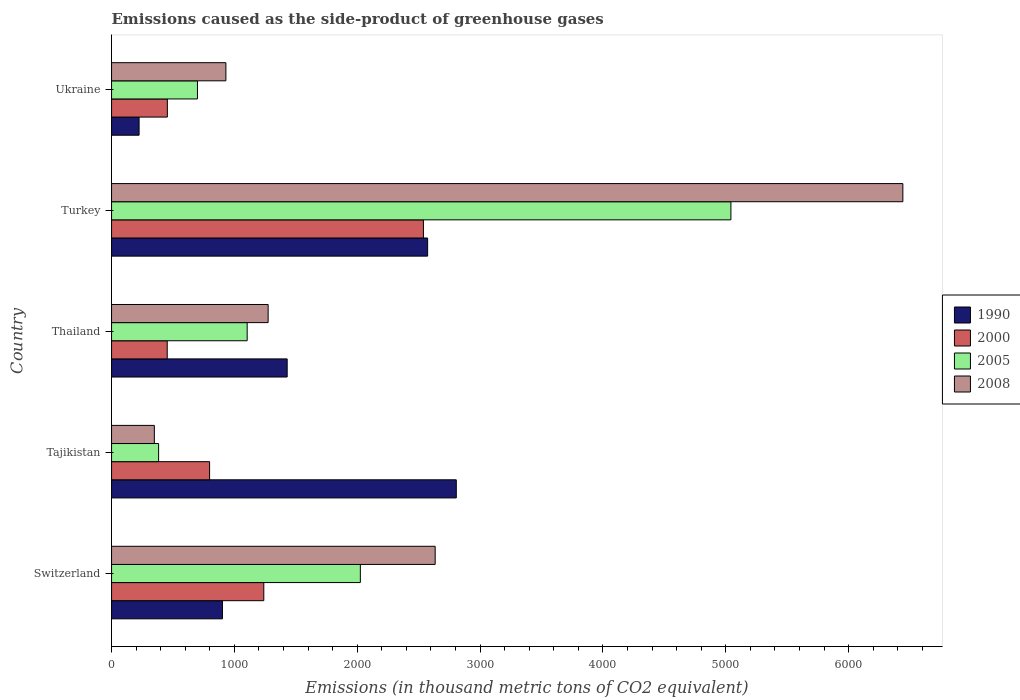How many different coloured bars are there?
Ensure brevity in your answer.  4. Are the number of bars per tick equal to the number of legend labels?
Provide a succinct answer. Yes. How many bars are there on the 4th tick from the bottom?
Make the answer very short. 4. What is the label of the 1st group of bars from the top?
Ensure brevity in your answer.  Ukraine. What is the emissions caused as the side-product of greenhouse gases in 2008 in Ukraine?
Make the answer very short. 930.6. Across all countries, what is the maximum emissions caused as the side-product of greenhouse gases in 1990?
Offer a terse response. 2806.1. Across all countries, what is the minimum emissions caused as the side-product of greenhouse gases in 2000?
Offer a very short reply. 453.1. In which country was the emissions caused as the side-product of greenhouse gases in 1990 maximum?
Your answer should be compact. Tajikistan. In which country was the emissions caused as the side-product of greenhouse gases in 1990 minimum?
Your answer should be very brief. Ukraine. What is the total emissions caused as the side-product of greenhouse gases in 2008 in the graph?
Offer a very short reply. 1.16e+04. What is the difference between the emissions caused as the side-product of greenhouse gases in 1990 in Thailand and that in Turkey?
Offer a terse response. -1143.2. What is the difference between the emissions caused as the side-product of greenhouse gases in 2000 in Tajikistan and the emissions caused as the side-product of greenhouse gases in 2008 in Thailand?
Provide a succinct answer. -476.5. What is the average emissions caused as the side-product of greenhouse gases in 2008 per country?
Give a very brief answer. 2325.7. What is the difference between the emissions caused as the side-product of greenhouse gases in 2005 and emissions caused as the side-product of greenhouse gases in 2008 in Switzerland?
Provide a short and direct response. -609.1. What is the ratio of the emissions caused as the side-product of greenhouse gases in 2000 in Switzerland to that in Turkey?
Your answer should be very brief. 0.49. Is the emissions caused as the side-product of greenhouse gases in 2005 in Thailand less than that in Ukraine?
Ensure brevity in your answer.  No. What is the difference between the highest and the second highest emissions caused as the side-product of greenhouse gases in 2000?
Give a very brief answer. 1299.3. What is the difference between the highest and the lowest emissions caused as the side-product of greenhouse gases in 1990?
Provide a succinct answer. 2582. Is the sum of the emissions caused as the side-product of greenhouse gases in 2000 in Tajikistan and Turkey greater than the maximum emissions caused as the side-product of greenhouse gases in 2008 across all countries?
Make the answer very short. No. Is it the case that in every country, the sum of the emissions caused as the side-product of greenhouse gases in 1990 and emissions caused as the side-product of greenhouse gases in 2005 is greater than the sum of emissions caused as the side-product of greenhouse gases in 2000 and emissions caused as the side-product of greenhouse gases in 2008?
Your response must be concise. No. What does the 4th bar from the top in Ukraine represents?
Ensure brevity in your answer.  1990. How many bars are there?
Your response must be concise. 20. What is the difference between two consecutive major ticks on the X-axis?
Your answer should be compact. 1000. Does the graph contain any zero values?
Provide a short and direct response. No. Does the graph contain grids?
Give a very brief answer. No. How many legend labels are there?
Offer a very short reply. 4. What is the title of the graph?
Offer a very short reply. Emissions caused as the side-product of greenhouse gases. What is the label or title of the X-axis?
Keep it short and to the point. Emissions (in thousand metric tons of CO2 equivalent). What is the Emissions (in thousand metric tons of CO2 equivalent) in 1990 in Switzerland?
Your answer should be compact. 902.6. What is the Emissions (in thousand metric tons of CO2 equivalent) in 2000 in Switzerland?
Give a very brief answer. 1239.2. What is the Emissions (in thousand metric tons of CO2 equivalent) of 2005 in Switzerland?
Your answer should be compact. 2025. What is the Emissions (in thousand metric tons of CO2 equivalent) of 2008 in Switzerland?
Make the answer very short. 2634.1. What is the Emissions (in thousand metric tons of CO2 equivalent) in 1990 in Tajikistan?
Provide a succinct answer. 2806.1. What is the Emissions (in thousand metric tons of CO2 equivalent) in 2000 in Tajikistan?
Provide a short and direct response. 798. What is the Emissions (in thousand metric tons of CO2 equivalent) in 2005 in Tajikistan?
Your answer should be very brief. 383. What is the Emissions (in thousand metric tons of CO2 equivalent) in 2008 in Tajikistan?
Keep it short and to the point. 348.3. What is the Emissions (in thousand metric tons of CO2 equivalent) in 1990 in Thailand?
Your answer should be very brief. 1429.5. What is the Emissions (in thousand metric tons of CO2 equivalent) in 2000 in Thailand?
Offer a very short reply. 453.1. What is the Emissions (in thousand metric tons of CO2 equivalent) of 2005 in Thailand?
Offer a very short reply. 1103.9. What is the Emissions (in thousand metric tons of CO2 equivalent) in 2008 in Thailand?
Your response must be concise. 1274.5. What is the Emissions (in thousand metric tons of CO2 equivalent) of 1990 in Turkey?
Offer a terse response. 2572.7. What is the Emissions (in thousand metric tons of CO2 equivalent) of 2000 in Turkey?
Provide a short and direct response. 2538.5. What is the Emissions (in thousand metric tons of CO2 equivalent) of 2005 in Turkey?
Ensure brevity in your answer.  5041.3. What is the Emissions (in thousand metric tons of CO2 equivalent) in 2008 in Turkey?
Your answer should be very brief. 6441. What is the Emissions (in thousand metric tons of CO2 equivalent) in 1990 in Ukraine?
Give a very brief answer. 224.1. What is the Emissions (in thousand metric tons of CO2 equivalent) of 2000 in Ukraine?
Ensure brevity in your answer.  454.2. What is the Emissions (in thousand metric tons of CO2 equivalent) of 2005 in Ukraine?
Give a very brief answer. 699.3. What is the Emissions (in thousand metric tons of CO2 equivalent) of 2008 in Ukraine?
Offer a very short reply. 930.6. Across all countries, what is the maximum Emissions (in thousand metric tons of CO2 equivalent) of 1990?
Your response must be concise. 2806.1. Across all countries, what is the maximum Emissions (in thousand metric tons of CO2 equivalent) of 2000?
Give a very brief answer. 2538.5. Across all countries, what is the maximum Emissions (in thousand metric tons of CO2 equivalent) in 2005?
Your response must be concise. 5041.3. Across all countries, what is the maximum Emissions (in thousand metric tons of CO2 equivalent) of 2008?
Your response must be concise. 6441. Across all countries, what is the minimum Emissions (in thousand metric tons of CO2 equivalent) in 1990?
Make the answer very short. 224.1. Across all countries, what is the minimum Emissions (in thousand metric tons of CO2 equivalent) of 2000?
Offer a terse response. 453.1. Across all countries, what is the minimum Emissions (in thousand metric tons of CO2 equivalent) in 2005?
Offer a terse response. 383. Across all countries, what is the minimum Emissions (in thousand metric tons of CO2 equivalent) of 2008?
Your answer should be compact. 348.3. What is the total Emissions (in thousand metric tons of CO2 equivalent) in 1990 in the graph?
Provide a short and direct response. 7935. What is the total Emissions (in thousand metric tons of CO2 equivalent) in 2000 in the graph?
Make the answer very short. 5483. What is the total Emissions (in thousand metric tons of CO2 equivalent) of 2005 in the graph?
Offer a very short reply. 9252.5. What is the total Emissions (in thousand metric tons of CO2 equivalent) in 2008 in the graph?
Offer a very short reply. 1.16e+04. What is the difference between the Emissions (in thousand metric tons of CO2 equivalent) in 1990 in Switzerland and that in Tajikistan?
Provide a short and direct response. -1903.5. What is the difference between the Emissions (in thousand metric tons of CO2 equivalent) in 2000 in Switzerland and that in Tajikistan?
Ensure brevity in your answer.  441.2. What is the difference between the Emissions (in thousand metric tons of CO2 equivalent) of 2005 in Switzerland and that in Tajikistan?
Provide a succinct answer. 1642. What is the difference between the Emissions (in thousand metric tons of CO2 equivalent) of 2008 in Switzerland and that in Tajikistan?
Keep it short and to the point. 2285.8. What is the difference between the Emissions (in thousand metric tons of CO2 equivalent) in 1990 in Switzerland and that in Thailand?
Provide a succinct answer. -526.9. What is the difference between the Emissions (in thousand metric tons of CO2 equivalent) in 2000 in Switzerland and that in Thailand?
Provide a short and direct response. 786.1. What is the difference between the Emissions (in thousand metric tons of CO2 equivalent) in 2005 in Switzerland and that in Thailand?
Your response must be concise. 921.1. What is the difference between the Emissions (in thousand metric tons of CO2 equivalent) of 2008 in Switzerland and that in Thailand?
Offer a terse response. 1359.6. What is the difference between the Emissions (in thousand metric tons of CO2 equivalent) of 1990 in Switzerland and that in Turkey?
Make the answer very short. -1670.1. What is the difference between the Emissions (in thousand metric tons of CO2 equivalent) of 2000 in Switzerland and that in Turkey?
Give a very brief answer. -1299.3. What is the difference between the Emissions (in thousand metric tons of CO2 equivalent) of 2005 in Switzerland and that in Turkey?
Provide a short and direct response. -3016.3. What is the difference between the Emissions (in thousand metric tons of CO2 equivalent) of 2008 in Switzerland and that in Turkey?
Make the answer very short. -3806.9. What is the difference between the Emissions (in thousand metric tons of CO2 equivalent) of 1990 in Switzerland and that in Ukraine?
Offer a terse response. 678.5. What is the difference between the Emissions (in thousand metric tons of CO2 equivalent) of 2000 in Switzerland and that in Ukraine?
Your response must be concise. 785. What is the difference between the Emissions (in thousand metric tons of CO2 equivalent) in 2005 in Switzerland and that in Ukraine?
Your answer should be compact. 1325.7. What is the difference between the Emissions (in thousand metric tons of CO2 equivalent) in 2008 in Switzerland and that in Ukraine?
Your response must be concise. 1703.5. What is the difference between the Emissions (in thousand metric tons of CO2 equivalent) of 1990 in Tajikistan and that in Thailand?
Ensure brevity in your answer.  1376.6. What is the difference between the Emissions (in thousand metric tons of CO2 equivalent) of 2000 in Tajikistan and that in Thailand?
Offer a terse response. 344.9. What is the difference between the Emissions (in thousand metric tons of CO2 equivalent) in 2005 in Tajikistan and that in Thailand?
Your answer should be compact. -720.9. What is the difference between the Emissions (in thousand metric tons of CO2 equivalent) of 2008 in Tajikistan and that in Thailand?
Ensure brevity in your answer.  -926.2. What is the difference between the Emissions (in thousand metric tons of CO2 equivalent) in 1990 in Tajikistan and that in Turkey?
Your response must be concise. 233.4. What is the difference between the Emissions (in thousand metric tons of CO2 equivalent) of 2000 in Tajikistan and that in Turkey?
Offer a terse response. -1740.5. What is the difference between the Emissions (in thousand metric tons of CO2 equivalent) of 2005 in Tajikistan and that in Turkey?
Offer a terse response. -4658.3. What is the difference between the Emissions (in thousand metric tons of CO2 equivalent) of 2008 in Tajikistan and that in Turkey?
Keep it short and to the point. -6092.7. What is the difference between the Emissions (in thousand metric tons of CO2 equivalent) of 1990 in Tajikistan and that in Ukraine?
Provide a succinct answer. 2582. What is the difference between the Emissions (in thousand metric tons of CO2 equivalent) of 2000 in Tajikistan and that in Ukraine?
Your answer should be very brief. 343.8. What is the difference between the Emissions (in thousand metric tons of CO2 equivalent) in 2005 in Tajikistan and that in Ukraine?
Your response must be concise. -316.3. What is the difference between the Emissions (in thousand metric tons of CO2 equivalent) in 2008 in Tajikistan and that in Ukraine?
Your response must be concise. -582.3. What is the difference between the Emissions (in thousand metric tons of CO2 equivalent) in 1990 in Thailand and that in Turkey?
Your response must be concise. -1143.2. What is the difference between the Emissions (in thousand metric tons of CO2 equivalent) of 2000 in Thailand and that in Turkey?
Provide a short and direct response. -2085.4. What is the difference between the Emissions (in thousand metric tons of CO2 equivalent) in 2005 in Thailand and that in Turkey?
Make the answer very short. -3937.4. What is the difference between the Emissions (in thousand metric tons of CO2 equivalent) in 2008 in Thailand and that in Turkey?
Give a very brief answer. -5166.5. What is the difference between the Emissions (in thousand metric tons of CO2 equivalent) in 1990 in Thailand and that in Ukraine?
Your answer should be very brief. 1205.4. What is the difference between the Emissions (in thousand metric tons of CO2 equivalent) of 2005 in Thailand and that in Ukraine?
Offer a very short reply. 404.6. What is the difference between the Emissions (in thousand metric tons of CO2 equivalent) of 2008 in Thailand and that in Ukraine?
Offer a very short reply. 343.9. What is the difference between the Emissions (in thousand metric tons of CO2 equivalent) of 1990 in Turkey and that in Ukraine?
Provide a succinct answer. 2348.6. What is the difference between the Emissions (in thousand metric tons of CO2 equivalent) of 2000 in Turkey and that in Ukraine?
Ensure brevity in your answer.  2084.3. What is the difference between the Emissions (in thousand metric tons of CO2 equivalent) of 2005 in Turkey and that in Ukraine?
Give a very brief answer. 4342. What is the difference between the Emissions (in thousand metric tons of CO2 equivalent) of 2008 in Turkey and that in Ukraine?
Your answer should be compact. 5510.4. What is the difference between the Emissions (in thousand metric tons of CO2 equivalent) of 1990 in Switzerland and the Emissions (in thousand metric tons of CO2 equivalent) of 2000 in Tajikistan?
Your answer should be compact. 104.6. What is the difference between the Emissions (in thousand metric tons of CO2 equivalent) of 1990 in Switzerland and the Emissions (in thousand metric tons of CO2 equivalent) of 2005 in Tajikistan?
Make the answer very short. 519.6. What is the difference between the Emissions (in thousand metric tons of CO2 equivalent) in 1990 in Switzerland and the Emissions (in thousand metric tons of CO2 equivalent) in 2008 in Tajikistan?
Your answer should be very brief. 554.3. What is the difference between the Emissions (in thousand metric tons of CO2 equivalent) in 2000 in Switzerland and the Emissions (in thousand metric tons of CO2 equivalent) in 2005 in Tajikistan?
Provide a succinct answer. 856.2. What is the difference between the Emissions (in thousand metric tons of CO2 equivalent) of 2000 in Switzerland and the Emissions (in thousand metric tons of CO2 equivalent) of 2008 in Tajikistan?
Ensure brevity in your answer.  890.9. What is the difference between the Emissions (in thousand metric tons of CO2 equivalent) of 2005 in Switzerland and the Emissions (in thousand metric tons of CO2 equivalent) of 2008 in Tajikistan?
Your answer should be compact. 1676.7. What is the difference between the Emissions (in thousand metric tons of CO2 equivalent) in 1990 in Switzerland and the Emissions (in thousand metric tons of CO2 equivalent) in 2000 in Thailand?
Make the answer very short. 449.5. What is the difference between the Emissions (in thousand metric tons of CO2 equivalent) in 1990 in Switzerland and the Emissions (in thousand metric tons of CO2 equivalent) in 2005 in Thailand?
Offer a very short reply. -201.3. What is the difference between the Emissions (in thousand metric tons of CO2 equivalent) in 1990 in Switzerland and the Emissions (in thousand metric tons of CO2 equivalent) in 2008 in Thailand?
Make the answer very short. -371.9. What is the difference between the Emissions (in thousand metric tons of CO2 equivalent) in 2000 in Switzerland and the Emissions (in thousand metric tons of CO2 equivalent) in 2005 in Thailand?
Offer a very short reply. 135.3. What is the difference between the Emissions (in thousand metric tons of CO2 equivalent) of 2000 in Switzerland and the Emissions (in thousand metric tons of CO2 equivalent) of 2008 in Thailand?
Provide a succinct answer. -35.3. What is the difference between the Emissions (in thousand metric tons of CO2 equivalent) in 2005 in Switzerland and the Emissions (in thousand metric tons of CO2 equivalent) in 2008 in Thailand?
Offer a terse response. 750.5. What is the difference between the Emissions (in thousand metric tons of CO2 equivalent) in 1990 in Switzerland and the Emissions (in thousand metric tons of CO2 equivalent) in 2000 in Turkey?
Provide a succinct answer. -1635.9. What is the difference between the Emissions (in thousand metric tons of CO2 equivalent) in 1990 in Switzerland and the Emissions (in thousand metric tons of CO2 equivalent) in 2005 in Turkey?
Your answer should be very brief. -4138.7. What is the difference between the Emissions (in thousand metric tons of CO2 equivalent) in 1990 in Switzerland and the Emissions (in thousand metric tons of CO2 equivalent) in 2008 in Turkey?
Your response must be concise. -5538.4. What is the difference between the Emissions (in thousand metric tons of CO2 equivalent) of 2000 in Switzerland and the Emissions (in thousand metric tons of CO2 equivalent) of 2005 in Turkey?
Keep it short and to the point. -3802.1. What is the difference between the Emissions (in thousand metric tons of CO2 equivalent) of 2000 in Switzerland and the Emissions (in thousand metric tons of CO2 equivalent) of 2008 in Turkey?
Ensure brevity in your answer.  -5201.8. What is the difference between the Emissions (in thousand metric tons of CO2 equivalent) of 2005 in Switzerland and the Emissions (in thousand metric tons of CO2 equivalent) of 2008 in Turkey?
Give a very brief answer. -4416. What is the difference between the Emissions (in thousand metric tons of CO2 equivalent) of 1990 in Switzerland and the Emissions (in thousand metric tons of CO2 equivalent) of 2000 in Ukraine?
Your response must be concise. 448.4. What is the difference between the Emissions (in thousand metric tons of CO2 equivalent) in 1990 in Switzerland and the Emissions (in thousand metric tons of CO2 equivalent) in 2005 in Ukraine?
Offer a very short reply. 203.3. What is the difference between the Emissions (in thousand metric tons of CO2 equivalent) in 1990 in Switzerland and the Emissions (in thousand metric tons of CO2 equivalent) in 2008 in Ukraine?
Your response must be concise. -28. What is the difference between the Emissions (in thousand metric tons of CO2 equivalent) of 2000 in Switzerland and the Emissions (in thousand metric tons of CO2 equivalent) of 2005 in Ukraine?
Offer a very short reply. 539.9. What is the difference between the Emissions (in thousand metric tons of CO2 equivalent) of 2000 in Switzerland and the Emissions (in thousand metric tons of CO2 equivalent) of 2008 in Ukraine?
Provide a succinct answer. 308.6. What is the difference between the Emissions (in thousand metric tons of CO2 equivalent) of 2005 in Switzerland and the Emissions (in thousand metric tons of CO2 equivalent) of 2008 in Ukraine?
Ensure brevity in your answer.  1094.4. What is the difference between the Emissions (in thousand metric tons of CO2 equivalent) in 1990 in Tajikistan and the Emissions (in thousand metric tons of CO2 equivalent) in 2000 in Thailand?
Offer a very short reply. 2353. What is the difference between the Emissions (in thousand metric tons of CO2 equivalent) of 1990 in Tajikistan and the Emissions (in thousand metric tons of CO2 equivalent) of 2005 in Thailand?
Make the answer very short. 1702.2. What is the difference between the Emissions (in thousand metric tons of CO2 equivalent) in 1990 in Tajikistan and the Emissions (in thousand metric tons of CO2 equivalent) in 2008 in Thailand?
Your response must be concise. 1531.6. What is the difference between the Emissions (in thousand metric tons of CO2 equivalent) in 2000 in Tajikistan and the Emissions (in thousand metric tons of CO2 equivalent) in 2005 in Thailand?
Give a very brief answer. -305.9. What is the difference between the Emissions (in thousand metric tons of CO2 equivalent) of 2000 in Tajikistan and the Emissions (in thousand metric tons of CO2 equivalent) of 2008 in Thailand?
Your response must be concise. -476.5. What is the difference between the Emissions (in thousand metric tons of CO2 equivalent) of 2005 in Tajikistan and the Emissions (in thousand metric tons of CO2 equivalent) of 2008 in Thailand?
Your answer should be compact. -891.5. What is the difference between the Emissions (in thousand metric tons of CO2 equivalent) of 1990 in Tajikistan and the Emissions (in thousand metric tons of CO2 equivalent) of 2000 in Turkey?
Ensure brevity in your answer.  267.6. What is the difference between the Emissions (in thousand metric tons of CO2 equivalent) of 1990 in Tajikistan and the Emissions (in thousand metric tons of CO2 equivalent) of 2005 in Turkey?
Your response must be concise. -2235.2. What is the difference between the Emissions (in thousand metric tons of CO2 equivalent) of 1990 in Tajikistan and the Emissions (in thousand metric tons of CO2 equivalent) of 2008 in Turkey?
Provide a succinct answer. -3634.9. What is the difference between the Emissions (in thousand metric tons of CO2 equivalent) in 2000 in Tajikistan and the Emissions (in thousand metric tons of CO2 equivalent) in 2005 in Turkey?
Make the answer very short. -4243.3. What is the difference between the Emissions (in thousand metric tons of CO2 equivalent) in 2000 in Tajikistan and the Emissions (in thousand metric tons of CO2 equivalent) in 2008 in Turkey?
Provide a short and direct response. -5643. What is the difference between the Emissions (in thousand metric tons of CO2 equivalent) of 2005 in Tajikistan and the Emissions (in thousand metric tons of CO2 equivalent) of 2008 in Turkey?
Your answer should be compact. -6058. What is the difference between the Emissions (in thousand metric tons of CO2 equivalent) in 1990 in Tajikistan and the Emissions (in thousand metric tons of CO2 equivalent) in 2000 in Ukraine?
Offer a terse response. 2351.9. What is the difference between the Emissions (in thousand metric tons of CO2 equivalent) in 1990 in Tajikistan and the Emissions (in thousand metric tons of CO2 equivalent) in 2005 in Ukraine?
Make the answer very short. 2106.8. What is the difference between the Emissions (in thousand metric tons of CO2 equivalent) in 1990 in Tajikistan and the Emissions (in thousand metric tons of CO2 equivalent) in 2008 in Ukraine?
Ensure brevity in your answer.  1875.5. What is the difference between the Emissions (in thousand metric tons of CO2 equivalent) in 2000 in Tajikistan and the Emissions (in thousand metric tons of CO2 equivalent) in 2005 in Ukraine?
Your answer should be compact. 98.7. What is the difference between the Emissions (in thousand metric tons of CO2 equivalent) in 2000 in Tajikistan and the Emissions (in thousand metric tons of CO2 equivalent) in 2008 in Ukraine?
Make the answer very short. -132.6. What is the difference between the Emissions (in thousand metric tons of CO2 equivalent) of 2005 in Tajikistan and the Emissions (in thousand metric tons of CO2 equivalent) of 2008 in Ukraine?
Offer a terse response. -547.6. What is the difference between the Emissions (in thousand metric tons of CO2 equivalent) of 1990 in Thailand and the Emissions (in thousand metric tons of CO2 equivalent) of 2000 in Turkey?
Your response must be concise. -1109. What is the difference between the Emissions (in thousand metric tons of CO2 equivalent) in 1990 in Thailand and the Emissions (in thousand metric tons of CO2 equivalent) in 2005 in Turkey?
Your answer should be very brief. -3611.8. What is the difference between the Emissions (in thousand metric tons of CO2 equivalent) of 1990 in Thailand and the Emissions (in thousand metric tons of CO2 equivalent) of 2008 in Turkey?
Ensure brevity in your answer.  -5011.5. What is the difference between the Emissions (in thousand metric tons of CO2 equivalent) in 2000 in Thailand and the Emissions (in thousand metric tons of CO2 equivalent) in 2005 in Turkey?
Offer a terse response. -4588.2. What is the difference between the Emissions (in thousand metric tons of CO2 equivalent) of 2000 in Thailand and the Emissions (in thousand metric tons of CO2 equivalent) of 2008 in Turkey?
Your answer should be compact. -5987.9. What is the difference between the Emissions (in thousand metric tons of CO2 equivalent) of 2005 in Thailand and the Emissions (in thousand metric tons of CO2 equivalent) of 2008 in Turkey?
Your answer should be very brief. -5337.1. What is the difference between the Emissions (in thousand metric tons of CO2 equivalent) of 1990 in Thailand and the Emissions (in thousand metric tons of CO2 equivalent) of 2000 in Ukraine?
Your answer should be compact. 975.3. What is the difference between the Emissions (in thousand metric tons of CO2 equivalent) in 1990 in Thailand and the Emissions (in thousand metric tons of CO2 equivalent) in 2005 in Ukraine?
Offer a terse response. 730.2. What is the difference between the Emissions (in thousand metric tons of CO2 equivalent) of 1990 in Thailand and the Emissions (in thousand metric tons of CO2 equivalent) of 2008 in Ukraine?
Ensure brevity in your answer.  498.9. What is the difference between the Emissions (in thousand metric tons of CO2 equivalent) in 2000 in Thailand and the Emissions (in thousand metric tons of CO2 equivalent) in 2005 in Ukraine?
Give a very brief answer. -246.2. What is the difference between the Emissions (in thousand metric tons of CO2 equivalent) in 2000 in Thailand and the Emissions (in thousand metric tons of CO2 equivalent) in 2008 in Ukraine?
Offer a very short reply. -477.5. What is the difference between the Emissions (in thousand metric tons of CO2 equivalent) in 2005 in Thailand and the Emissions (in thousand metric tons of CO2 equivalent) in 2008 in Ukraine?
Give a very brief answer. 173.3. What is the difference between the Emissions (in thousand metric tons of CO2 equivalent) in 1990 in Turkey and the Emissions (in thousand metric tons of CO2 equivalent) in 2000 in Ukraine?
Offer a very short reply. 2118.5. What is the difference between the Emissions (in thousand metric tons of CO2 equivalent) in 1990 in Turkey and the Emissions (in thousand metric tons of CO2 equivalent) in 2005 in Ukraine?
Make the answer very short. 1873.4. What is the difference between the Emissions (in thousand metric tons of CO2 equivalent) of 1990 in Turkey and the Emissions (in thousand metric tons of CO2 equivalent) of 2008 in Ukraine?
Offer a terse response. 1642.1. What is the difference between the Emissions (in thousand metric tons of CO2 equivalent) in 2000 in Turkey and the Emissions (in thousand metric tons of CO2 equivalent) in 2005 in Ukraine?
Ensure brevity in your answer.  1839.2. What is the difference between the Emissions (in thousand metric tons of CO2 equivalent) in 2000 in Turkey and the Emissions (in thousand metric tons of CO2 equivalent) in 2008 in Ukraine?
Provide a short and direct response. 1607.9. What is the difference between the Emissions (in thousand metric tons of CO2 equivalent) in 2005 in Turkey and the Emissions (in thousand metric tons of CO2 equivalent) in 2008 in Ukraine?
Your answer should be compact. 4110.7. What is the average Emissions (in thousand metric tons of CO2 equivalent) of 1990 per country?
Your answer should be very brief. 1587. What is the average Emissions (in thousand metric tons of CO2 equivalent) of 2000 per country?
Your response must be concise. 1096.6. What is the average Emissions (in thousand metric tons of CO2 equivalent) in 2005 per country?
Provide a short and direct response. 1850.5. What is the average Emissions (in thousand metric tons of CO2 equivalent) of 2008 per country?
Ensure brevity in your answer.  2325.7. What is the difference between the Emissions (in thousand metric tons of CO2 equivalent) of 1990 and Emissions (in thousand metric tons of CO2 equivalent) of 2000 in Switzerland?
Give a very brief answer. -336.6. What is the difference between the Emissions (in thousand metric tons of CO2 equivalent) in 1990 and Emissions (in thousand metric tons of CO2 equivalent) in 2005 in Switzerland?
Provide a succinct answer. -1122.4. What is the difference between the Emissions (in thousand metric tons of CO2 equivalent) in 1990 and Emissions (in thousand metric tons of CO2 equivalent) in 2008 in Switzerland?
Make the answer very short. -1731.5. What is the difference between the Emissions (in thousand metric tons of CO2 equivalent) of 2000 and Emissions (in thousand metric tons of CO2 equivalent) of 2005 in Switzerland?
Offer a very short reply. -785.8. What is the difference between the Emissions (in thousand metric tons of CO2 equivalent) in 2000 and Emissions (in thousand metric tons of CO2 equivalent) in 2008 in Switzerland?
Give a very brief answer. -1394.9. What is the difference between the Emissions (in thousand metric tons of CO2 equivalent) of 2005 and Emissions (in thousand metric tons of CO2 equivalent) of 2008 in Switzerland?
Provide a short and direct response. -609.1. What is the difference between the Emissions (in thousand metric tons of CO2 equivalent) of 1990 and Emissions (in thousand metric tons of CO2 equivalent) of 2000 in Tajikistan?
Offer a very short reply. 2008.1. What is the difference between the Emissions (in thousand metric tons of CO2 equivalent) in 1990 and Emissions (in thousand metric tons of CO2 equivalent) in 2005 in Tajikistan?
Ensure brevity in your answer.  2423.1. What is the difference between the Emissions (in thousand metric tons of CO2 equivalent) in 1990 and Emissions (in thousand metric tons of CO2 equivalent) in 2008 in Tajikistan?
Your response must be concise. 2457.8. What is the difference between the Emissions (in thousand metric tons of CO2 equivalent) of 2000 and Emissions (in thousand metric tons of CO2 equivalent) of 2005 in Tajikistan?
Make the answer very short. 415. What is the difference between the Emissions (in thousand metric tons of CO2 equivalent) of 2000 and Emissions (in thousand metric tons of CO2 equivalent) of 2008 in Tajikistan?
Provide a succinct answer. 449.7. What is the difference between the Emissions (in thousand metric tons of CO2 equivalent) in 2005 and Emissions (in thousand metric tons of CO2 equivalent) in 2008 in Tajikistan?
Give a very brief answer. 34.7. What is the difference between the Emissions (in thousand metric tons of CO2 equivalent) in 1990 and Emissions (in thousand metric tons of CO2 equivalent) in 2000 in Thailand?
Offer a very short reply. 976.4. What is the difference between the Emissions (in thousand metric tons of CO2 equivalent) in 1990 and Emissions (in thousand metric tons of CO2 equivalent) in 2005 in Thailand?
Your answer should be compact. 325.6. What is the difference between the Emissions (in thousand metric tons of CO2 equivalent) of 1990 and Emissions (in thousand metric tons of CO2 equivalent) of 2008 in Thailand?
Your answer should be very brief. 155. What is the difference between the Emissions (in thousand metric tons of CO2 equivalent) of 2000 and Emissions (in thousand metric tons of CO2 equivalent) of 2005 in Thailand?
Make the answer very short. -650.8. What is the difference between the Emissions (in thousand metric tons of CO2 equivalent) in 2000 and Emissions (in thousand metric tons of CO2 equivalent) in 2008 in Thailand?
Keep it short and to the point. -821.4. What is the difference between the Emissions (in thousand metric tons of CO2 equivalent) of 2005 and Emissions (in thousand metric tons of CO2 equivalent) of 2008 in Thailand?
Offer a very short reply. -170.6. What is the difference between the Emissions (in thousand metric tons of CO2 equivalent) in 1990 and Emissions (in thousand metric tons of CO2 equivalent) in 2000 in Turkey?
Your answer should be very brief. 34.2. What is the difference between the Emissions (in thousand metric tons of CO2 equivalent) in 1990 and Emissions (in thousand metric tons of CO2 equivalent) in 2005 in Turkey?
Provide a short and direct response. -2468.6. What is the difference between the Emissions (in thousand metric tons of CO2 equivalent) in 1990 and Emissions (in thousand metric tons of CO2 equivalent) in 2008 in Turkey?
Offer a terse response. -3868.3. What is the difference between the Emissions (in thousand metric tons of CO2 equivalent) of 2000 and Emissions (in thousand metric tons of CO2 equivalent) of 2005 in Turkey?
Your answer should be compact. -2502.8. What is the difference between the Emissions (in thousand metric tons of CO2 equivalent) in 2000 and Emissions (in thousand metric tons of CO2 equivalent) in 2008 in Turkey?
Keep it short and to the point. -3902.5. What is the difference between the Emissions (in thousand metric tons of CO2 equivalent) of 2005 and Emissions (in thousand metric tons of CO2 equivalent) of 2008 in Turkey?
Your answer should be compact. -1399.7. What is the difference between the Emissions (in thousand metric tons of CO2 equivalent) in 1990 and Emissions (in thousand metric tons of CO2 equivalent) in 2000 in Ukraine?
Ensure brevity in your answer.  -230.1. What is the difference between the Emissions (in thousand metric tons of CO2 equivalent) of 1990 and Emissions (in thousand metric tons of CO2 equivalent) of 2005 in Ukraine?
Offer a terse response. -475.2. What is the difference between the Emissions (in thousand metric tons of CO2 equivalent) in 1990 and Emissions (in thousand metric tons of CO2 equivalent) in 2008 in Ukraine?
Ensure brevity in your answer.  -706.5. What is the difference between the Emissions (in thousand metric tons of CO2 equivalent) in 2000 and Emissions (in thousand metric tons of CO2 equivalent) in 2005 in Ukraine?
Make the answer very short. -245.1. What is the difference between the Emissions (in thousand metric tons of CO2 equivalent) in 2000 and Emissions (in thousand metric tons of CO2 equivalent) in 2008 in Ukraine?
Provide a short and direct response. -476.4. What is the difference between the Emissions (in thousand metric tons of CO2 equivalent) in 2005 and Emissions (in thousand metric tons of CO2 equivalent) in 2008 in Ukraine?
Your answer should be compact. -231.3. What is the ratio of the Emissions (in thousand metric tons of CO2 equivalent) in 1990 in Switzerland to that in Tajikistan?
Offer a very short reply. 0.32. What is the ratio of the Emissions (in thousand metric tons of CO2 equivalent) in 2000 in Switzerland to that in Tajikistan?
Keep it short and to the point. 1.55. What is the ratio of the Emissions (in thousand metric tons of CO2 equivalent) of 2005 in Switzerland to that in Tajikistan?
Provide a short and direct response. 5.29. What is the ratio of the Emissions (in thousand metric tons of CO2 equivalent) of 2008 in Switzerland to that in Tajikistan?
Your response must be concise. 7.56. What is the ratio of the Emissions (in thousand metric tons of CO2 equivalent) of 1990 in Switzerland to that in Thailand?
Your answer should be compact. 0.63. What is the ratio of the Emissions (in thousand metric tons of CO2 equivalent) of 2000 in Switzerland to that in Thailand?
Your answer should be compact. 2.73. What is the ratio of the Emissions (in thousand metric tons of CO2 equivalent) of 2005 in Switzerland to that in Thailand?
Offer a terse response. 1.83. What is the ratio of the Emissions (in thousand metric tons of CO2 equivalent) in 2008 in Switzerland to that in Thailand?
Your response must be concise. 2.07. What is the ratio of the Emissions (in thousand metric tons of CO2 equivalent) of 1990 in Switzerland to that in Turkey?
Offer a terse response. 0.35. What is the ratio of the Emissions (in thousand metric tons of CO2 equivalent) of 2000 in Switzerland to that in Turkey?
Provide a short and direct response. 0.49. What is the ratio of the Emissions (in thousand metric tons of CO2 equivalent) in 2005 in Switzerland to that in Turkey?
Keep it short and to the point. 0.4. What is the ratio of the Emissions (in thousand metric tons of CO2 equivalent) of 2008 in Switzerland to that in Turkey?
Give a very brief answer. 0.41. What is the ratio of the Emissions (in thousand metric tons of CO2 equivalent) of 1990 in Switzerland to that in Ukraine?
Provide a succinct answer. 4.03. What is the ratio of the Emissions (in thousand metric tons of CO2 equivalent) in 2000 in Switzerland to that in Ukraine?
Keep it short and to the point. 2.73. What is the ratio of the Emissions (in thousand metric tons of CO2 equivalent) of 2005 in Switzerland to that in Ukraine?
Provide a succinct answer. 2.9. What is the ratio of the Emissions (in thousand metric tons of CO2 equivalent) of 2008 in Switzerland to that in Ukraine?
Offer a terse response. 2.83. What is the ratio of the Emissions (in thousand metric tons of CO2 equivalent) in 1990 in Tajikistan to that in Thailand?
Provide a succinct answer. 1.96. What is the ratio of the Emissions (in thousand metric tons of CO2 equivalent) in 2000 in Tajikistan to that in Thailand?
Offer a very short reply. 1.76. What is the ratio of the Emissions (in thousand metric tons of CO2 equivalent) in 2005 in Tajikistan to that in Thailand?
Your answer should be very brief. 0.35. What is the ratio of the Emissions (in thousand metric tons of CO2 equivalent) of 2008 in Tajikistan to that in Thailand?
Keep it short and to the point. 0.27. What is the ratio of the Emissions (in thousand metric tons of CO2 equivalent) of 1990 in Tajikistan to that in Turkey?
Your answer should be compact. 1.09. What is the ratio of the Emissions (in thousand metric tons of CO2 equivalent) in 2000 in Tajikistan to that in Turkey?
Keep it short and to the point. 0.31. What is the ratio of the Emissions (in thousand metric tons of CO2 equivalent) in 2005 in Tajikistan to that in Turkey?
Give a very brief answer. 0.08. What is the ratio of the Emissions (in thousand metric tons of CO2 equivalent) of 2008 in Tajikistan to that in Turkey?
Make the answer very short. 0.05. What is the ratio of the Emissions (in thousand metric tons of CO2 equivalent) in 1990 in Tajikistan to that in Ukraine?
Keep it short and to the point. 12.52. What is the ratio of the Emissions (in thousand metric tons of CO2 equivalent) in 2000 in Tajikistan to that in Ukraine?
Offer a very short reply. 1.76. What is the ratio of the Emissions (in thousand metric tons of CO2 equivalent) of 2005 in Tajikistan to that in Ukraine?
Your response must be concise. 0.55. What is the ratio of the Emissions (in thousand metric tons of CO2 equivalent) in 2008 in Tajikistan to that in Ukraine?
Provide a short and direct response. 0.37. What is the ratio of the Emissions (in thousand metric tons of CO2 equivalent) of 1990 in Thailand to that in Turkey?
Make the answer very short. 0.56. What is the ratio of the Emissions (in thousand metric tons of CO2 equivalent) of 2000 in Thailand to that in Turkey?
Give a very brief answer. 0.18. What is the ratio of the Emissions (in thousand metric tons of CO2 equivalent) in 2005 in Thailand to that in Turkey?
Make the answer very short. 0.22. What is the ratio of the Emissions (in thousand metric tons of CO2 equivalent) of 2008 in Thailand to that in Turkey?
Offer a terse response. 0.2. What is the ratio of the Emissions (in thousand metric tons of CO2 equivalent) in 1990 in Thailand to that in Ukraine?
Offer a very short reply. 6.38. What is the ratio of the Emissions (in thousand metric tons of CO2 equivalent) of 2000 in Thailand to that in Ukraine?
Make the answer very short. 1. What is the ratio of the Emissions (in thousand metric tons of CO2 equivalent) of 2005 in Thailand to that in Ukraine?
Give a very brief answer. 1.58. What is the ratio of the Emissions (in thousand metric tons of CO2 equivalent) of 2008 in Thailand to that in Ukraine?
Offer a very short reply. 1.37. What is the ratio of the Emissions (in thousand metric tons of CO2 equivalent) of 1990 in Turkey to that in Ukraine?
Your response must be concise. 11.48. What is the ratio of the Emissions (in thousand metric tons of CO2 equivalent) in 2000 in Turkey to that in Ukraine?
Offer a very short reply. 5.59. What is the ratio of the Emissions (in thousand metric tons of CO2 equivalent) in 2005 in Turkey to that in Ukraine?
Ensure brevity in your answer.  7.21. What is the ratio of the Emissions (in thousand metric tons of CO2 equivalent) of 2008 in Turkey to that in Ukraine?
Your response must be concise. 6.92. What is the difference between the highest and the second highest Emissions (in thousand metric tons of CO2 equivalent) of 1990?
Offer a terse response. 233.4. What is the difference between the highest and the second highest Emissions (in thousand metric tons of CO2 equivalent) in 2000?
Your answer should be compact. 1299.3. What is the difference between the highest and the second highest Emissions (in thousand metric tons of CO2 equivalent) of 2005?
Keep it short and to the point. 3016.3. What is the difference between the highest and the second highest Emissions (in thousand metric tons of CO2 equivalent) in 2008?
Provide a succinct answer. 3806.9. What is the difference between the highest and the lowest Emissions (in thousand metric tons of CO2 equivalent) of 1990?
Your answer should be very brief. 2582. What is the difference between the highest and the lowest Emissions (in thousand metric tons of CO2 equivalent) in 2000?
Ensure brevity in your answer.  2085.4. What is the difference between the highest and the lowest Emissions (in thousand metric tons of CO2 equivalent) of 2005?
Offer a terse response. 4658.3. What is the difference between the highest and the lowest Emissions (in thousand metric tons of CO2 equivalent) of 2008?
Your answer should be very brief. 6092.7. 